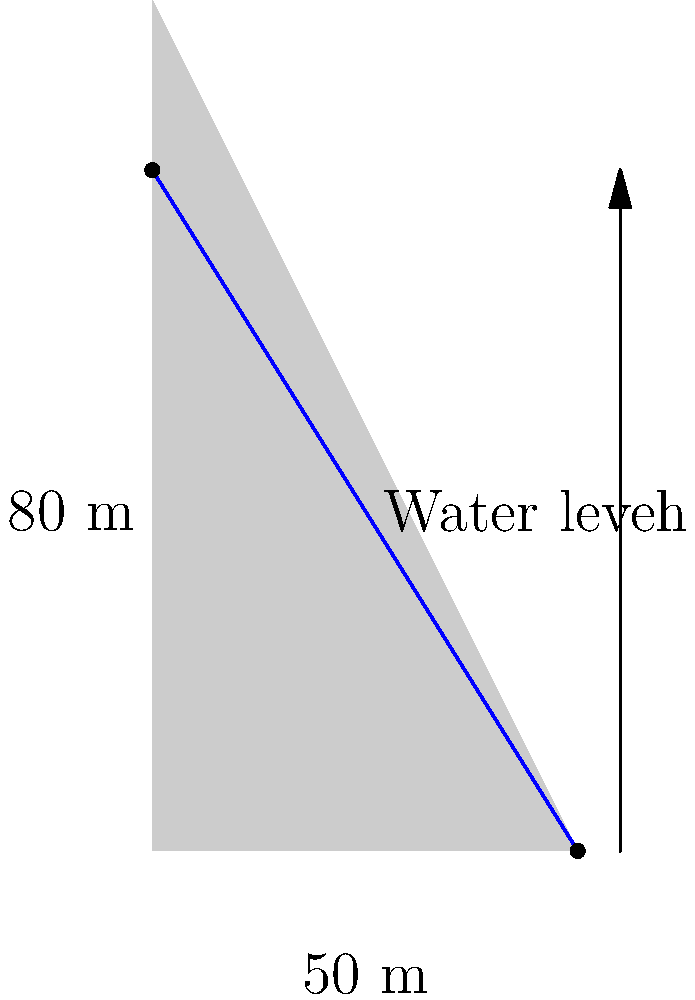As a singer-songwriter who appreciates the harmony in various musical eras, consider the balance of forces in a dam. A triangular dam has a height of 80 meters and a base width of 50 meters. If the water level reaches the top of the dam, what is the water pressure (in kPa) at the base of the dam? Assume the density of water is 1000 kg/m³ and gravitational acceleration is 9.81 m/s². To solve this problem, we'll follow these steps:

1) The water pressure at the base of the dam is determined by the depth of water above it. In this case, it's the full height of the dam.

2) The formula for hydrostatic pressure is:

   $$P = \rho g h$$

   Where:
   $P$ = pressure
   $\rho$ (rho) = density of water
   $g$ = gravitational acceleration
   $h$ = height of water column

3) We're given:
   $\rho = 1000$ kg/m³
   $g = 9.81$ m/s²
   $h = 80$ m

4) Let's substitute these values into our equation:

   $$P = 1000 \text{ kg/m³} \times 9.81 \text{ m/s²} \times 80 \text{ m}$$

5) Calculating:
   $$P = 784,800 \text{ N/m²}$$

6) Convert N/m² to kPa:
   $$P = 784.8 \text{ kPa}$$

Just as different musical elements come together to create a harmonious composition, the interplay of water density, gravity, and dam height results in the pressure at the base.
Answer: 784.8 kPa 